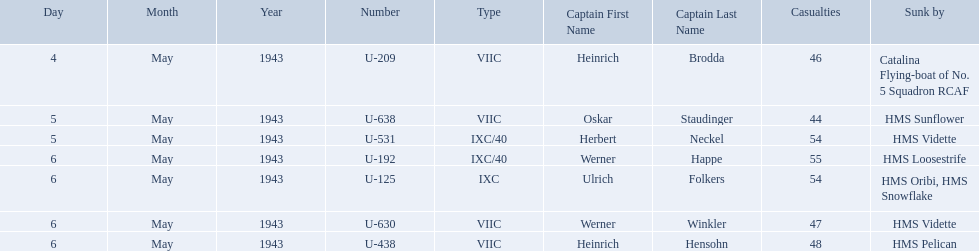What boats were lost on may 5? U-638, U-531. Who were the captains of those boats? Oskar Staudinger, Herbert Neckel. Which captain was not oskar staudinger? Herbert Neckel. Who were the captains in the ons 5 convoy? Heinrich Brodda, Oskar Staudinger, Herbert Neckel, Werner Happe, Ulrich Folkers, Werner Winkler, Heinrich Hensohn. Which ones lost their u-boat on may 5? Oskar Staudinger, Herbert Neckel. Of those, which one is not oskar staudinger? Herbert Neckel. Who are the captains of the u boats? Heinrich Brodda, Oskar Staudinger, Herbert Neckel, Werner Happe, Ulrich Folkers, Werner Winkler, Heinrich Hensohn. What are the dates the u boat captains were lost? 4 May 1943, 5 May 1943, 5 May 1943, 6 May 1943, 6 May 1943, 6 May 1943, 6 May 1943. Of these, which were lost on may 5? Oskar Staudinger, Herbert Neckel. Other than oskar staudinger, who else was lost on this day? Herbert Neckel. 